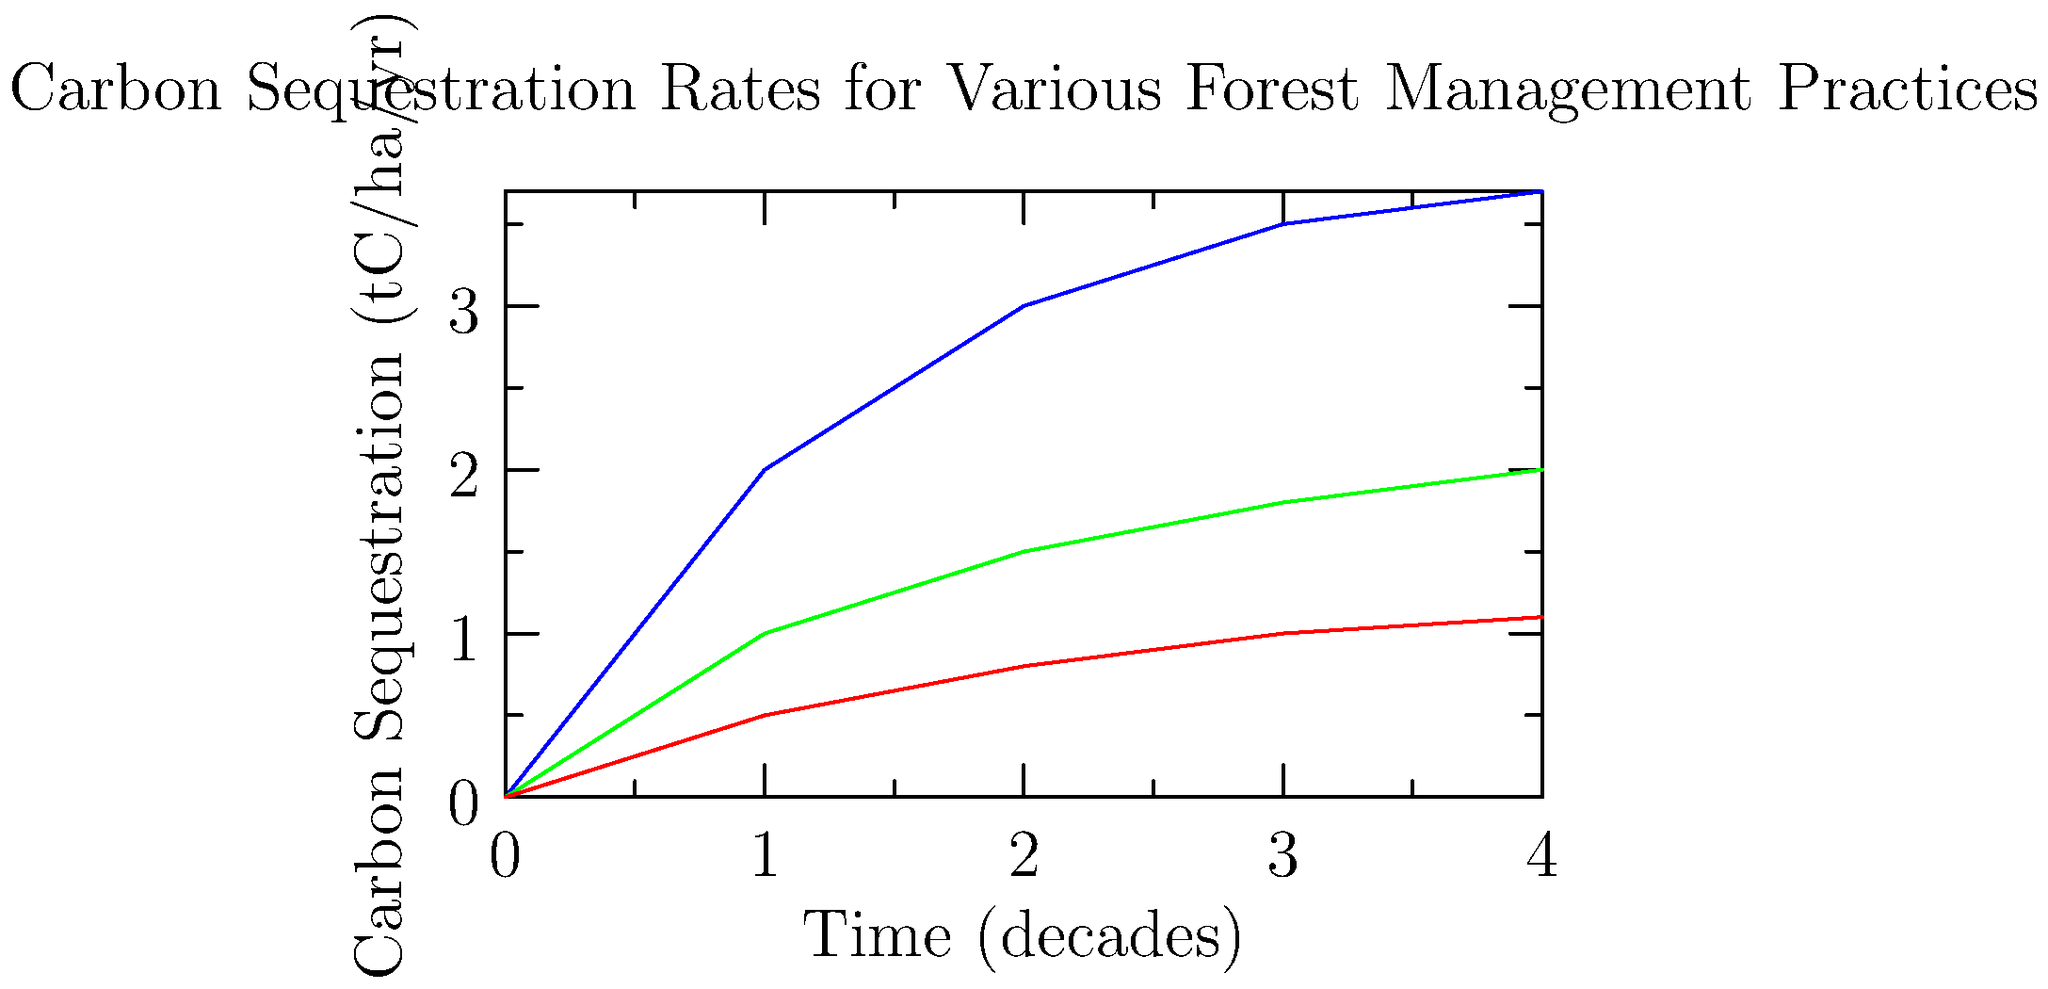Based on the graph, which forest management practice shows the highest carbon sequestration rate after 4 decades, and how much higher is it compared to the least effective practice? To answer this question, we need to follow these steps:

1. Identify the three forest management practices shown in the graph:
   - Blue line: Sustainable
   - Green line: Moderate
   - Red line: Unsustainable

2. Locate the carbon sequestration rates at the 4-decade mark:
   - Sustainable (blue): approximately 3.7 tC/ha/yr
   - Moderate (green): approximately 2.0 tC/ha/yr
   - Unsustainable (red): approximately 1.1 tC/ha/yr

3. Determine the highest and lowest sequestration rates:
   - Highest: Sustainable at 3.7 tC/ha/yr
   - Lowest: Unsustainable at 1.1 tC/ha/yr

4. Calculate the difference between the highest and lowest rates:
   $$3.7 \text{ tC/ha/yr} - 1.1 \text{ tC/ha/yr} = 2.6 \text{ tC/ha/yr}$$

Therefore, the sustainable practice shows the highest carbon sequestration rate after 4 decades, and it is 2.6 tC/ha/yr higher than the unsustainable practice, which is the least effective.
Answer: Sustainable; 2.6 tC/ha/yr higher 